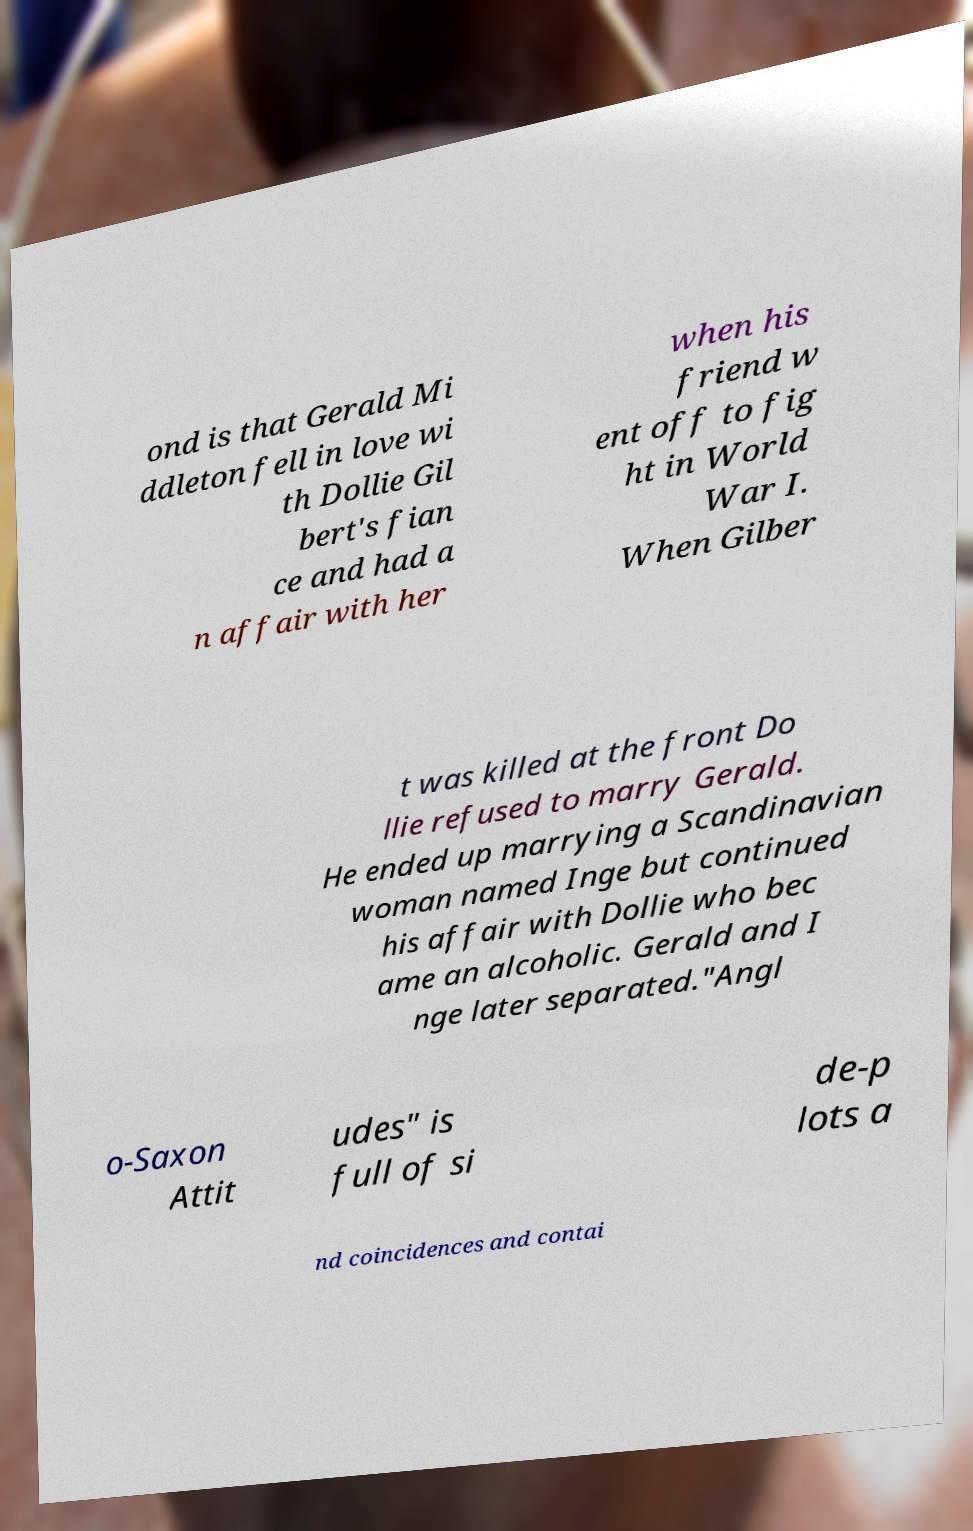What messages or text are displayed in this image? I need them in a readable, typed format. ond is that Gerald Mi ddleton fell in love wi th Dollie Gil bert's fian ce and had a n affair with her when his friend w ent off to fig ht in World War I. When Gilber t was killed at the front Do llie refused to marry Gerald. He ended up marrying a Scandinavian woman named Inge but continued his affair with Dollie who bec ame an alcoholic. Gerald and I nge later separated."Angl o-Saxon Attit udes" is full of si de-p lots a nd coincidences and contai 